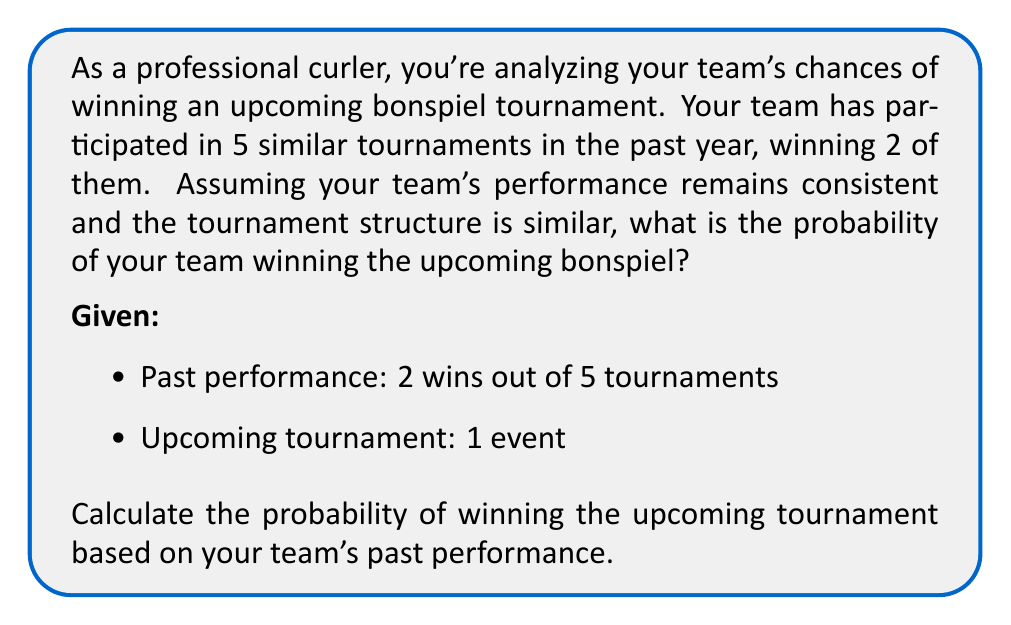Teach me how to tackle this problem. To solve this problem, we'll use the concept of relative frequency as an estimate for probability. Here's a step-by-step explanation:

1) First, we need to calculate the relative frequency of winning based on past performance:

   $$ P(\text{winning}) = \frac{\text{Number of wins}}{\text{Total number of tournaments}} $$

2) Substituting the given values:

   $$ P(\text{winning}) = \frac{2}{5} = 0.4 $$

3) This means that based on past performance, the probability of winning any given tournament is 0.4 or 40%.

4) Since we're assuming that the team's performance remains consistent and the tournament structure is similar, we can use this probability for the upcoming tournament.

5) Therefore, the probability of winning the upcoming bonspiel is 0.4 or 40%.

Note: In reality, many other factors could influence the actual probability, such as the skill level of other teams, changes in team composition, or variations in tournament format. This calculation provides a simplified estimate based solely on past performance.
Answer: 0.4 